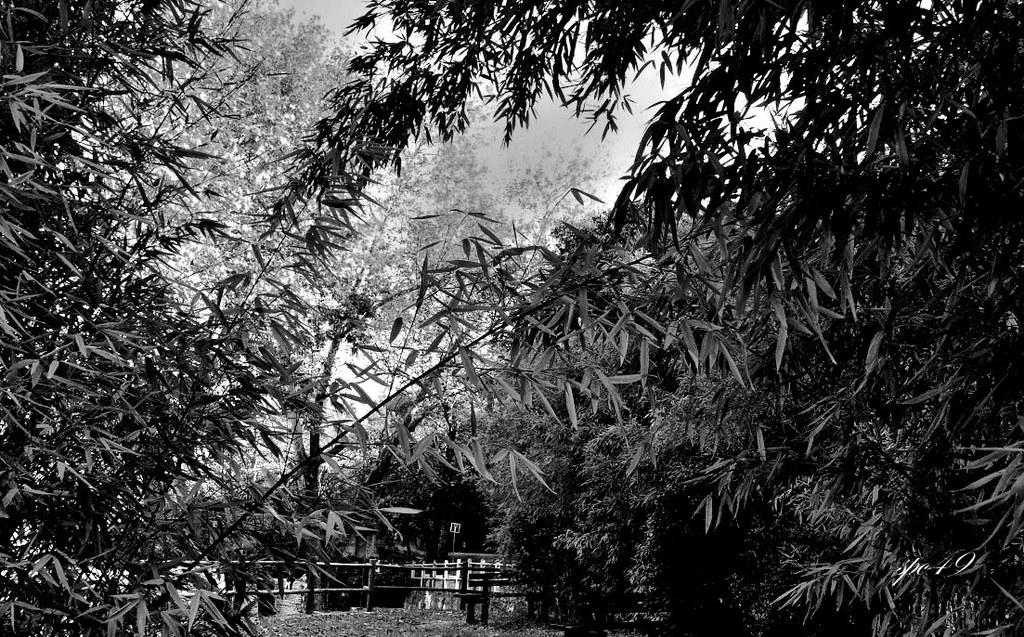What type of fence is present in the image? There is a metal rod fence in the image. What can be seen behind the fence? Water is visible behind the fence. What type of vegetation is present around the fence? There are trees around the fence. What type of spring can be seen in the image? There is no spring present in the image. 